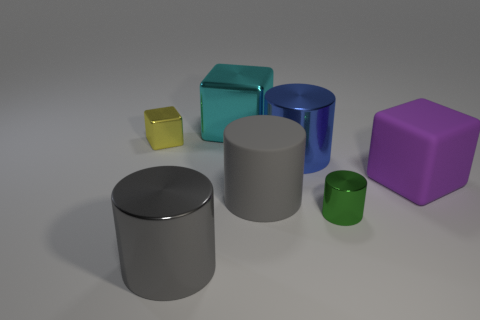There is a yellow cube that is made of the same material as the big blue object; what size is it?
Provide a short and direct response. Small. Is the number of blue cylinders greater than the number of yellow balls?
Keep it short and to the point. Yes. There is a big object that is behind the small yellow cube; what color is it?
Provide a short and direct response. Cyan. There is a cylinder that is both behind the green thing and in front of the big purple thing; what size is it?
Ensure brevity in your answer.  Large. How many yellow matte spheres have the same size as the gray shiny thing?
Make the answer very short. 0. There is a big blue object that is the same shape as the small green thing; what is it made of?
Your answer should be compact. Metal. Is the shape of the green thing the same as the yellow shiny object?
Provide a short and direct response. No. There is a big gray shiny cylinder; what number of small metallic cylinders are to the left of it?
Keep it short and to the point. 0. What shape is the tiny metal thing that is on the left side of the metal cube that is behind the small yellow object?
Ensure brevity in your answer.  Cube. There is a object that is made of the same material as the large purple block; what is its shape?
Your response must be concise. Cylinder. 